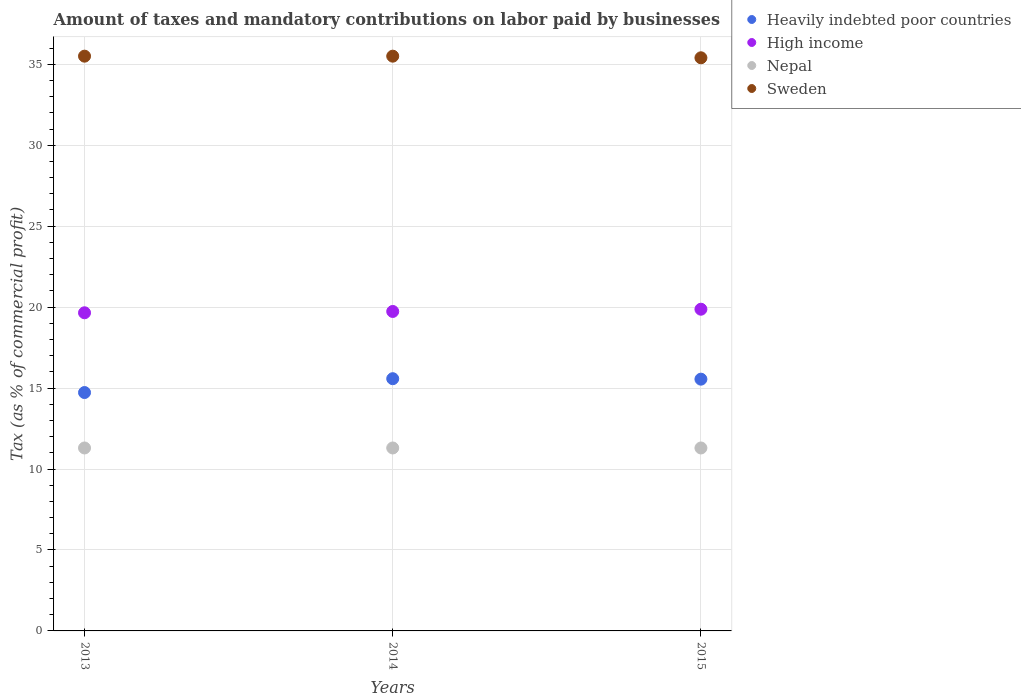What is the percentage of taxes paid by businesses in High income in 2013?
Keep it short and to the point. 19.65. Across all years, what is the maximum percentage of taxes paid by businesses in Sweden?
Provide a short and direct response. 35.5. Across all years, what is the minimum percentage of taxes paid by businesses in Nepal?
Your response must be concise. 11.3. In which year was the percentage of taxes paid by businesses in High income maximum?
Make the answer very short. 2015. What is the total percentage of taxes paid by businesses in Nepal in the graph?
Your answer should be very brief. 33.9. What is the difference between the percentage of taxes paid by businesses in Sweden in 2013 and that in 2014?
Offer a terse response. 0. What is the difference between the percentage of taxes paid by businesses in Heavily indebted poor countries in 2015 and the percentage of taxes paid by businesses in Nepal in 2014?
Your answer should be compact. 4.25. What is the average percentage of taxes paid by businesses in Heavily indebted poor countries per year?
Offer a very short reply. 15.28. In the year 2013, what is the difference between the percentage of taxes paid by businesses in High income and percentage of taxes paid by businesses in Sweden?
Provide a succinct answer. -15.85. What is the ratio of the percentage of taxes paid by businesses in Nepal in 2013 to that in 2014?
Give a very brief answer. 1. What is the difference between the highest and the second highest percentage of taxes paid by businesses in Heavily indebted poor countries?
Give a very brief answer. 0.03. What is the difference between the highest and the lowest percentage of taxes paid by businesses in High income?
Give a very brief answer. 0.22. Is the sum of the percentage of taxes paid by businesses in High income in 2014 and 2015 greater than the maximum percentage of taxes paid by businesses in Heavily indebted poor countries across all years?
Ensure brevity in your answer.  Yes. Is it the case that in every year, the sum of the percentage of taxes paid by businesses in Nepal and percentage of taxes paid by businesses in High income  is greater than the sum of percentage of taxes paid by businesses in Heavily indebted poor countries and percentage of taxes paid by businesses in Sweden?
Your answer should be very brief. No. Is the percentage of taxes paid by businesses in Nepal strictly greater than the percentage of taxes paid by businesses in Sweden over the years?
Your answer should be very brief. No. How many years are there in the graph?
Provide a succinct answer. 3. What is the difference between two consecutive major ticks on the Y-axis?
Keep it short and to the point. 5. Are the values on the major ticks of Y-axis written in scientific E-notation?
Keep it short and to the point. No. Does the graph contain any zero values?
Your response must be concise. No. Where does the legend appear in the graph?
Give a very brief answer. Top right. How many legend labels are there?
Make the answer very short. 4. How are the legend labels stacked?
Provide a short and direct response. Vertical. What is the title of the graph?
Provide a short and direct response. Amount of taxes and mandatory contributions on labor paid by businesses. Does "Ecuador" appear as one of the legend labels in the graph?
Keep it short and to the point. No. What is the label or title of the Y-axis?
Give a very brief answer. Tax (as % of commercial profit). What is the Tax (as % of commercial profit) of Heavily indebted poor countries in 2013?
Keep it short and to the point. 14.72. What is the Tax (as % of commercial profit) of High income in 2013?
Keep it short and to the point. 19.65. What is the Tax (as % of commercial profit) in Nepal in 2013?
Your answer should be compact. 11.3. What is the Tax (as % of commercial profit) of Sweden in 2013?
Keep it short and to the point. 35.5. What is the Tax (as % of commercial profit) in Heavily indebted poor countries in 2014?
Offer a terse response. 15.58. What is the Tax (as % of commercial profit) of High income in 2014?
Make the answer very short. 19.73. What is the Tax (as % of commercial profit) of Sweden in 2014?
Provide a short and direct response. 35.5. What is the Tax (as % of commercial profit) in Heavily indebted poor countries in 2015?
Offer a terse response. 15.55. What is the Tax (as % of commercial profit) in High income in 2015?
Offer a very short reply. 19.87. What is the Tax (as % of commercial profit) in Sweden in 2015?
Provide a succinct answer. 35.4. Across all years, what is the maximum Tax (as % of commercial profit) of Heavily indebted poor countries?
Make the answer very short. 15.58. Across all years, what is the maximum Tax (as % of commercial profit) of High income?
Offer a terse response. 19.87. Across all years, what is the maximum Tax (as % of commercial profit) of Nepal?
Provide a short and direct response. 11.3. Across all years, what is the maximum Tax (as % of commercial profit) in Sweden?
Provide a short and direct response. 35.5. Across all years, what is the minimum Tax (as % of commercial profit) in Heavily indebted poor countries?
Keep it short and to the point. 14.72. Across all years, what is the minimum Tax (as % of commercial profit) in High income?
Offer a very short reply. 19.65. Across all years, what is the minimum Tax (as % of commercial profit) in Nepal?
Offer a very short reply. 11.3. Across all years, what is the minimum Tax (as % of commercial profit) of Sweden?
Ensure brevity in your answer.  35.4. What is the total Tax (as % of commercial profit) in Heavily indebted poor countries in the graph?
Your answer should be compact. 45.85. What is the total Tax (as % of commercial profit) in High income in the graph?
Your answer should be compact. 59.25. What is the total Tax (as % of commercial profit) of Nepal in the graph?
Ensure brevity in your answer.  33.9. What is the total Tax (as % of commercial profit) in Sweden in the graph?
Make the answer very short. 106.4. What is the difference between the Tax (as % of commercial profit) in Heavily indebted poor countries in 2013 and that in 2014?
Offer a terse response. -0.86. What is the difference between the Tax (as % of commercial profit) of High income in 2013 and that in 2014?
Ensure brevity in your answer.  -0.08. What is the difference between the Tax (as % of commercial profit) of Sweden in 2013 and that in 2014?
Your answer should be compact. 0. What is the difference between the Tax (as % of commercial profit) of Heavily indebted poor countries in 2013 and that in 2015?
Provide a short and direct response. -0.83. What is the difference between the Tax (as % of commercial profit) of High income in 2013 and that in 2015?
Offer a very short reply. -0.22. What is the difference between the Tax (as % of commercial profit) in Nepal in 2013 and that in 2015?
Your response must be concise. 0. What is the difference between the Tax (as % of commercial profit) in Sweden in 2013 and that in 2015?
Give a very brief answer. 0.1. What is the difference between the Tax (as % of commercial profit) of Heavily indebted poor countries in 2014 and that in 2015?
Make the answer very short. 0.03. What is the difference between the Tax (as % of commercial profit) of High income in 2014 and that in 2015?
Your answer should be very brief. -0.14. What is the difference between the Tax (as % of commercial profit) in Nepal in 2014 and that in 2015?
Give a very brief answer. 0. What is the difference between the Tax (as % of commercial profit) of Sweden in 2014 and that in 2015?
Make the answer very short. 0.1. What is the difference between the Tax (as % of commercial profit) of Heavily indebted poor countries in 2013 and the Tax (as % of commercial profit) of High income in 2014?
Your response must be concise. -5.01. What is the difference between the Tax (as % of commercial profit) of Heavily indebted poor countries in 2013 and the Tax (as % of commercial profit) of Nepal in 2014?
Your answer should be compact. 3.42. What is the difference between the Tax (as % of commercial profit) of Heavily indebted poor countries in 2013 and the Tax (as % of commercial profit) of Sweden in 2014?
Provide a succinct answer. -20.78. What is the difference between the Tax (as % of commercial profit) of High income in 2013 and the Tax (as % of commercial profit) of Nepal in 2014?
Your answer should be very brief. 8.35. What is the difference between the Tax (as % of commercial profit) of High income in 2013 and the Tax (as % of commercial profit) of Sweden in 2014?
Offer a very short reply. -15.85. What is the difference between the Tax (as % of commercial profit) in Nepal in 2013 and the Tax (as % of commercial profit) in Sweden in 2014?
Your answer should be very brief. -24.2. What is the difference between the Tax (as % of commercial profit) in Heavily indebted poor countries in 2013 and the Tax (as % of commercial profit) in High income in 2015?
Your answer should be very brief. -5.15. What is the difference between the Tax (as % of commercial profit) in Heavily indebted poor countries in 2013 and the Tax (as % of commercial profit) in Nepal in 2015?
Your answer should be compact. 3.42. What is the difference between the Tax (as % of commercial profit) in Heavily indebted poor countries in 2013 and the Tax (as % of commercial profit) in Sweden in 2015?
Your response must be concise. -20.68. What is the difference between the Tax (as % of commercial profit) of High income in 2013 and the Tax (as % of commercial profit) of Nepal in 2015?
Offer a very short reply. 8.35. What is the difference between the Tax (as % of commercial profit) in High income in 2013 and the Tax (as % of commercial profit) in Sweden in 2015?
Make the answer very short. -15.75. What is the difference between the Tax (as % of commercial profit) in Nepal in 2013 and the Tax (as % of commercial profit) in Sweden in 2015?
Ensure brevity in your answer.  -24.1. What is the difference between the Tax (as % of commercial profit) of Heavily indebted poor countries in 2014 and the Tax (as % of commercial profit) of High income in 2015?
Your answer should be compact. -4.29. What is the difference between the Tax (as % of commercial profit) of Heavily indebted poor countries in 2014 and the Tax (as % of commercial profit) of Nepal in 2015?
Offer a terse response. 4.28. What is the difference between the Tax (as % of commercial profit) of Heavily indebted poor countries in 2014 and the Tax (as % of commercial profit) of Sweden in 2015?
Offer a very short reply. -19.82. What is the difference between the Tax (as % of commercial profit) of High income in 2014 and the Tax (as % of commercial profit) of Nepal in 2015?
Ensure brevity in your answer.  8.43. What is the difference between the Tax (as % of commercial profit) in High income in 2014 and the Tax (as % of commercial profit) in Sweden in 2015?
Provide a short and direct response. -15.67. What is the difference between the Tax (as % of commercial profit) in Nepal in 2014 and the Tax (as % of commercial profit) in Sweden in 2015?
Make the answer very short. -24.1. What is the average Tax (as % of commercial profit) of Heavily indebted poor countries per year?
Your answer should be compact. 15.28. What is the average Tax (as % of commercial profit) of High income per year?
Offer a terse response. 19.75. What is the average Tax (as % of commercial profit) of Sweden per year?
Provide a short and direct response. 35.47. In the year 2013, what is the difference between the Tax (as % of commercial profit) in Heavily indebted poor countries and Tax (as % of commercial profit) in High income?
Your answer should be compact. -4.93. In the year 2013, what is the difference between the Tax (as % of commercial profit) of Heavily indebted poor countries and Tax (as % of commercial profit) of Nepal?
Your answer should be very brief. 3.42. In the year 2013, what is the difference between the Tax (as % of commercial profit) in Heavily indebted poor countries and Tax (as % of commercial profit) in Sweden?
Provide a succinct answer. -20.78. In the year 2013, what is the difference between the Tax (as % of commercial profit) in High income and Tax (as % of commercial profit) in Nepal?
Your answer should be compact. 8.35. In the year 2013, what is the difference between the Tax (as % of commercial profit) of High income and Tax (as % of commercial profit) of Sweden?
Provide a succinct answer. -15.85. In the year 2013, what is the difference between the Tax (as % of commercial profit) in Nepal and Tax (as % of commercial profit) in Sweden?
Provide a short and direct response. -24.2. In the year 2014, what is the difference between the Tax (as % of commercial profit) of Heavily indebted poor countries and Tax (as % of commercial profit) of High income?
Your answer should be compact. -4.15. In the year 2014, what is the difference between the Tax (as % of commercial profit) of Heavily indebted poor countries and Tax (as % of commercial profit) of Nepal?
Keep it short and to the point. 4.28. In the year 2014, what is the difference between the Tax (as % of commercial profit) of Heavily indebted poor countries and Tax (as % of commercial profit) of Sweden?
Provide a succinct answer. -19.92. In the year 2014, what is the difference between the Tax (as % of commercial profit) in High income and Tax (as % of commercial profit) in Nepal?
Make the answer very short. 8.43. In the year 2014, what is the difference between the Tax (as % of commercial profit) of High income and Tax (as % of commercial profit) of Sweden?
Provide a short and direct response. -15.77. In the year 2014, what is the difference between the Tax (as % of commercial profit) in Nepal and Tax (as % of commercial profit) in Sweden?
Offer a terse response. -24.2. In the year 2015, what is the difference between the Tax (as % of commercial profit) of Heavily indebted poor countries and Tax (as % of commercial profit) of High income?
Give a very brief answer. -4.32. In the year 2015, what is the difference between the Tax (as % of commercial profit) in Heavily indebted poor countries and Tax (as % of commercial profit) in Nepal?
Your response must be concise. 4.25. In the year 2015, what is the difference between the Tax (as % of commercial profit) in Heavily indebted poor countries and Tax (as % of commercial profit) in Sweden?
Give a very brief answer. -19.85. In the year 2015, what is the difference between the Tax (as % of commercial profit) in High income and Tax (as % of commercial profit) in Nepal?
Ensure brevity in your answer.  8.57. In the year 2015, what is the difference between the Tax (as % of commercial profit) of High income and Tax (as % of commercial profit) of Sweden?
Give a very brief answer. -15.53. In the year 2015, what is the difference between the Tax (as % of commercial profit) in Nepal and Tax (as % of commercial profit) in Sweden?
Give a very brief answer. -24.1. What is the ratio of the Tax (as % of commercial profit) of Heavily indebted poor countries in 2013 to that in 2014?
Your answer should be very brief. 0.95. What is the ratio of the Tax (as % of commercial profit) in Nepal in 2013 to that in 2014?
Offer a terse response. 1. What is the ratio of the Tax (as % of commercial profit) in Sweden in 2013 to that in 2014?
Your answer should be compact. 1. What is the ratio of the Tax (as % of commercial profit) of Heavily indebted poor countries in 2013 to that in 2015?
Keep it short and to the point. 0.95. What is the ratio of the Tax (as % of commercial profit) of High income in 2013 to that in 2015?
Give a very brief answer. 0.99. What is the ratio of the Tax (as % of commercial profit) of Nepal in 2013 to that in 2015?
Offer a terse response. 1. What is the ratio of the Tax (as % of commercial profit) in High income in 2014 to that in 2015?
Your response must be concise. 0.99. What is the ratio of the Tax (as % of commercial profit) in Sweden in 2014 to that in 2015?
Make the answer very short. 1. What is the difference between the highest and the second highest Tax (as % of commercial profit) of Heavily indebted poor countries?
Your answer should be compact. 0.03. What is the difference between the highest and the second highest Tax (as % of commercial profit) in High income?
Your answer should be very brief. 0.14. What is the difference between the highest and the second highest Tax (as % of commercial profit) of Nepal?
Your answer should be very brief. 0. What is the difference between the highest and the lowest Tax (as % of commercial profit) of Heavily indebted poor countries?
Offer a terse response. 0.86. What is the difference between the highest and the lowest Tax (as % of commercial profit) in High income?
Your answer should be compact. 0.22. What is the difference between the highest and the lowest Tax (as % of commercial profit) in Sweden?
Provide a succinct answer. 0.1. 